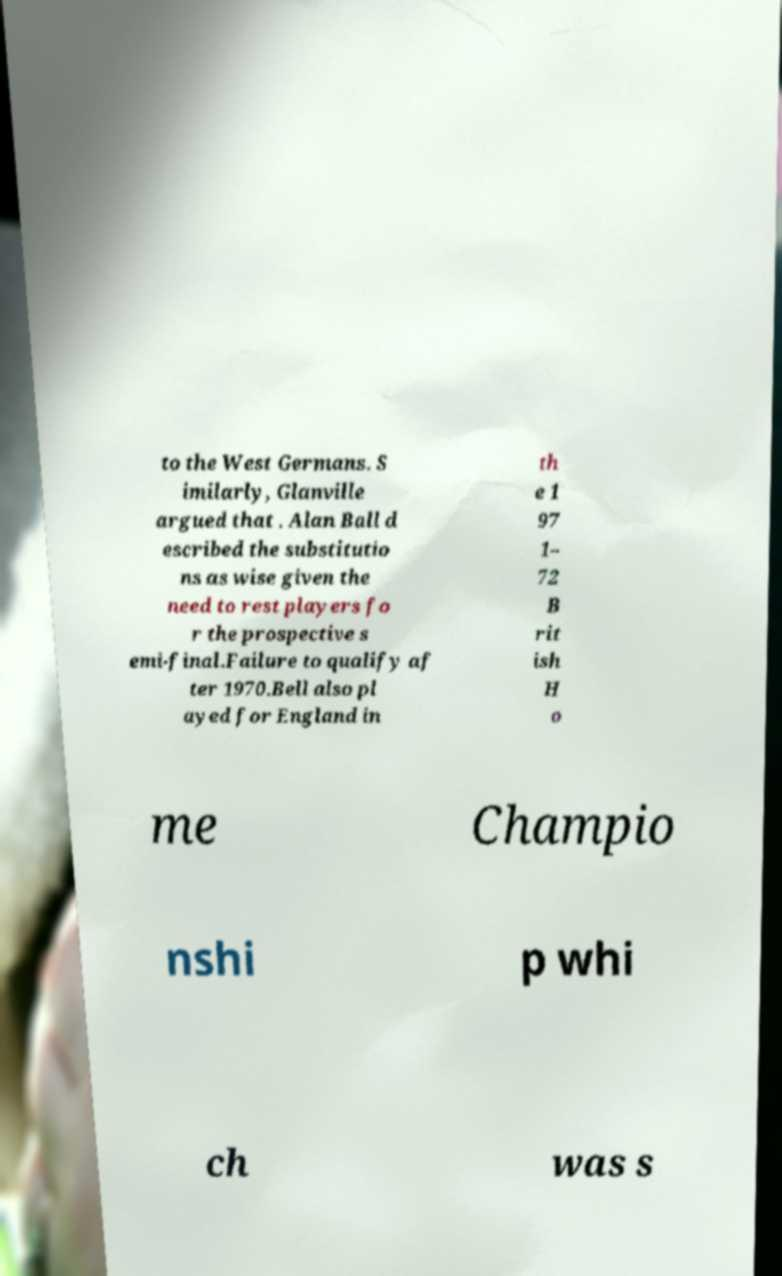What messages or text are displayed in this image? I need them in a readable, typed format. to the West Germans. S imilarly, Glanville argued that . Alan Ball d escribed the substitutio ns as wise given the need to rest players fo r the prospective s emi-final.Failure to qualify af ter 1970.Bell also pl ayed for England in th e 1 97 1– 72 B rit ish H o me Champio nshi p whi ch was s 